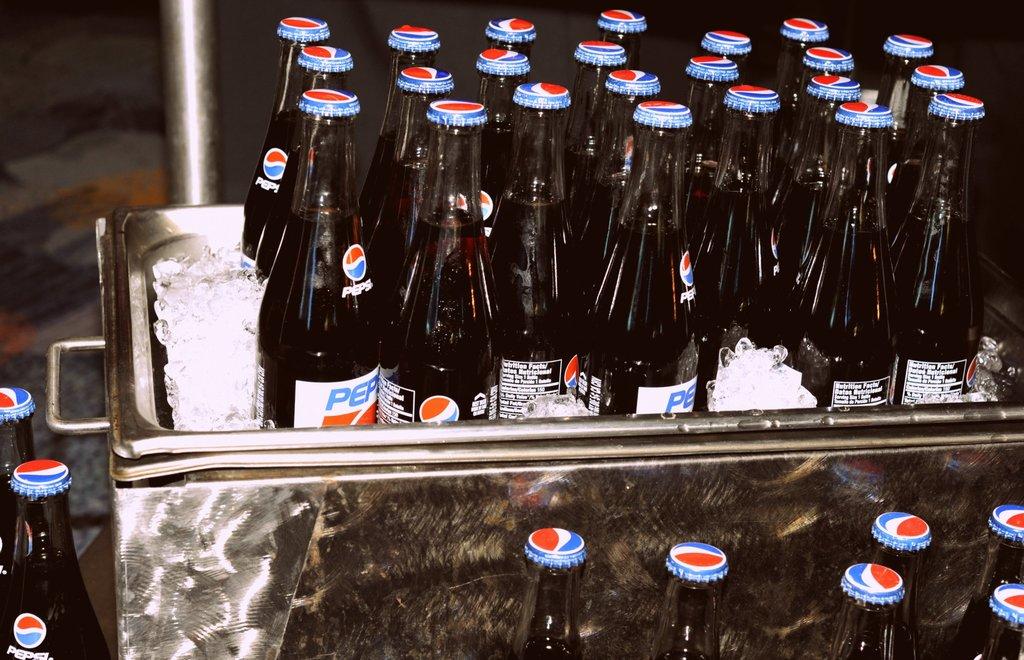What kind of soda is in the cooler?
Ensure brevity in your answer.  Pepsi. 